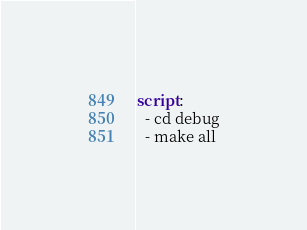Convert code to text. <code><loc_0><loc_0><loc_500><loc_500><_YAML_>script:
  - cd debug
  - make all
</code> 